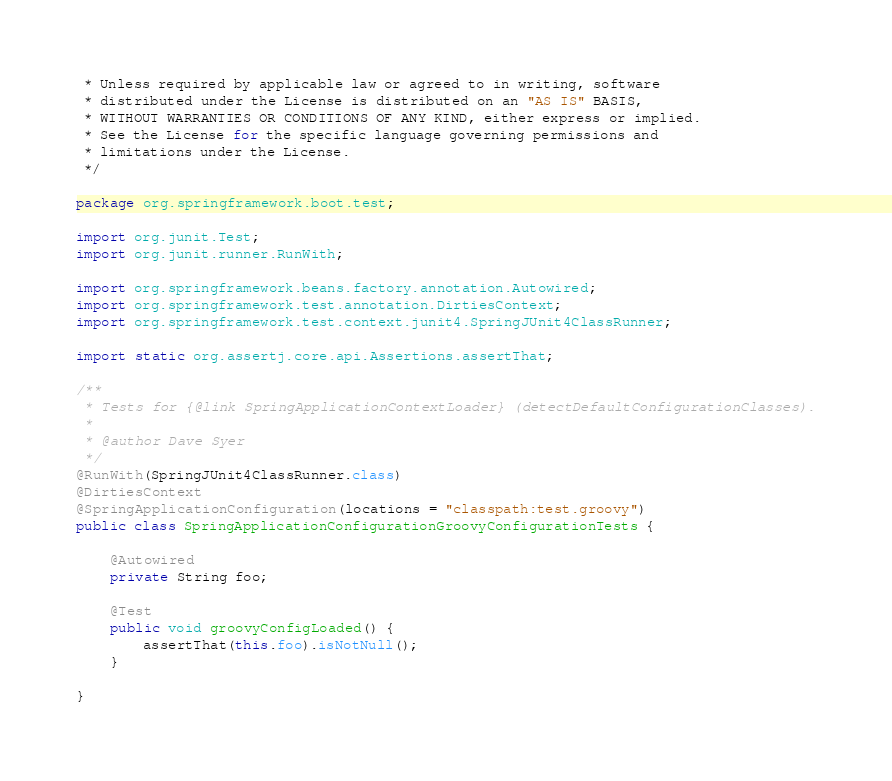Convert code to text. <code><loc_0><loc_0><loc_500><loc_500><_Java_> * Unless required by applicable law or agreed to in writing, software
 * distributed under the License is distributed on an "AS IS" BASIS,
 * WITHOUT WARRANTIES OR CONDITIONS OF ANY KIND, either express or implied.
 * See the License for the specific language governing permissions and
 * limitations under the License.
 */

package org.springframework.boot.test;

import org.junit.Test;
import org.junit.runner.RunWith;

import org.springframework.beans.factory.annotation.Autowired;
import org.springframework.test.annotation.DirtiesContext;
import org.springframework.test.context.junit4.SpringJUnit4ClassRunner;

import static org.assertj.core.api.Assertions.assertThat;

/**
 * Tests for {@link SpringApplicationContextLoader} (detectDefaultConfigurationClasses).
 *
 * @author Dave Syer
 */
@RunWith(SpringJUnit4ClassRunner.class)
@DirtiesContext
@SpringApplicationConfiguration(locations = "classpath:test.groovy")
public class SpringApplicationConfigurationGroovyConfigurationTests {

	@Autowired
	private String foo;

	@Test
	public void groovyConfigLoaded() {
		assertThat(this.foo).isNotNull();
	}

}
</code> 